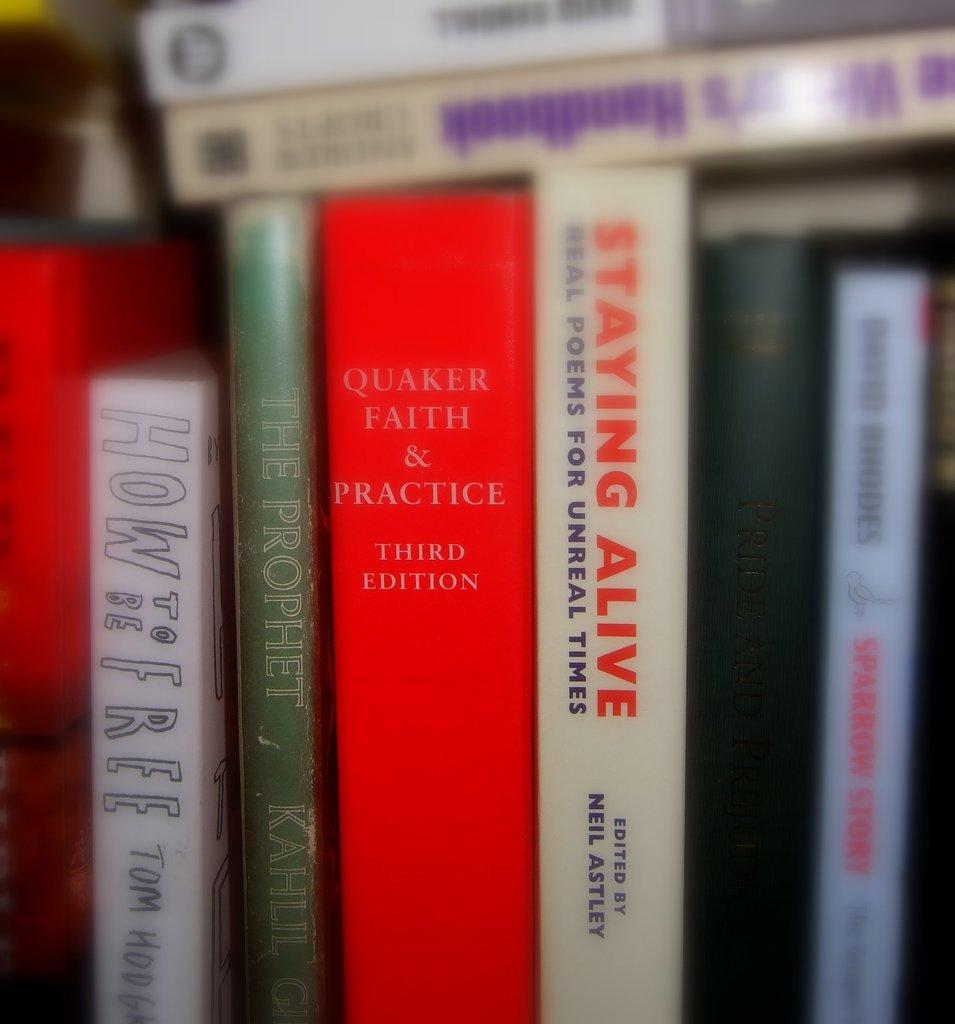<image>
Summarize the visual content of the image. a stack of books with one saying staying alive in red 